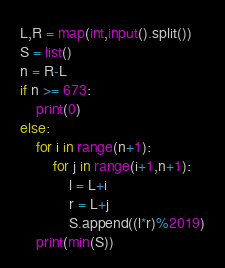<code> <loc_0><loc_0><loc_500><loc_500><_Python_>L,R = map(int,input().split())
S = list()
n = R-L
if n >= 673:
    print(0)
else:
    for i in range(n+1):
        for j in range(i+1,n+1):
            l = L+i
            r = L+j
            S.append((l*r)%2019)
    print(min(S))</code> 